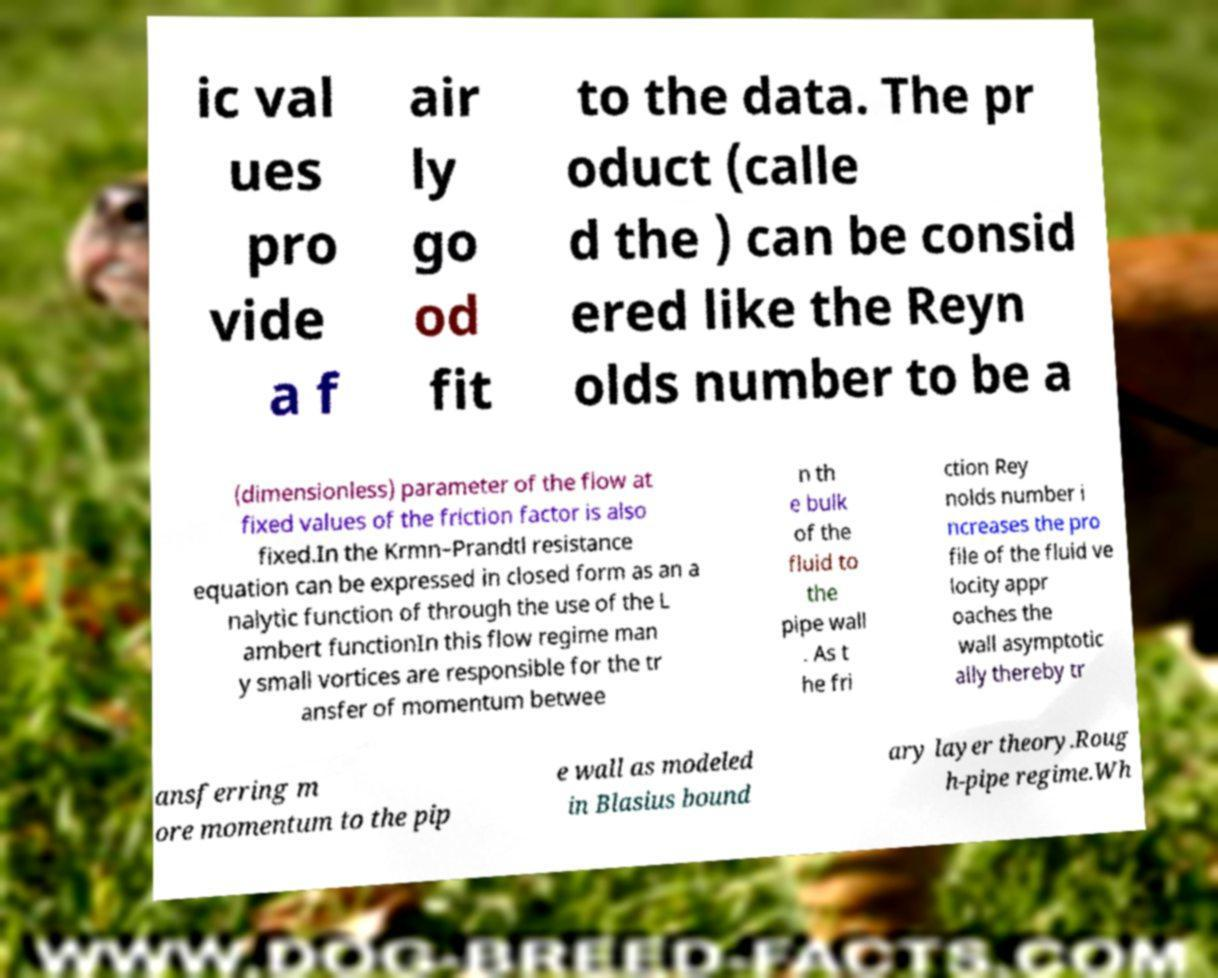For documentation purposes, I need the text within this image transcribed. Could you provide that? ic val ues pro vide a f air ly go od fit to the data. The pr oduct (calle d the ) can be consid ered like the Reyn olds number to be a (dimensionless) parameter of the flow at fixed values of the friction factor is also fixed.In the Krmn–Prandtl resistance equation can be expressed in closed form as an a nalytic function of through the use of the L ambert functionIn this flow regime man y small vortices are responsible for the tr ansfer of momentum betwee n th e bulk of the fluid to the pipe wall . As t he fri ction Rey nolds number i ncreases the pro file of the fluid ve locity appr oaches the wall asymptotic ally thereby tr ansferring m ore momentum to the pip e wall as modeled in Blasius bound ary layer theory.Roug h-pipe regime.Wh 